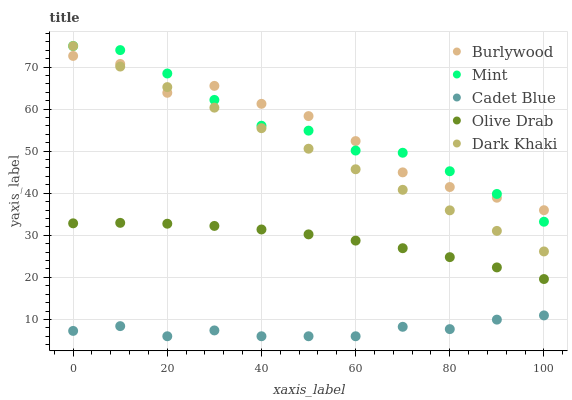Does Cadet Blue have the minimum area under the curve?
Answer yes or no. Yes. Does Mint have the maximum area under the curve?
Answer yes or no. Yes. Does Dark Khaki have the minimum area under the curve?
Answer yes or no. No. Does Dark Khaki have the maximum area under the curve?
Answer yes or no. No. Is Dark Khaki the smoothest?
Answer yes or no. Yes. Is Burlywood the roughest?
Answer yes or no. Yes. Is Cadet Blue the smoothest?
Answer yes or no. No. Is Cadet Blue the roughest?
Answer yes or no. No. Does Cadet Blue have the lowest value?
Answer yes or no. Yes. Does Dark Khaki have the lowest value?
Answer yes or no. No. Does Mint have the highest value?
Answer yes or no. Yes. Does Cadet Blue have the highest value?
Answer yes or no. No. Is Cadet Blue less than Mint?
Answer yes or no. Yes. Is Olive Drab greater than Cadet Blue?
Answer yes or no. Yes. Does Burlywood intersect Mint?
Answer yes or no. Yes. Is Burlywood less than Mint?
Answer yes or no. No. Is Burlywood greater than Mint?
Answer yes or no. No. Does Cadet Blue intersect Mint?
Answer yes or no. No. 